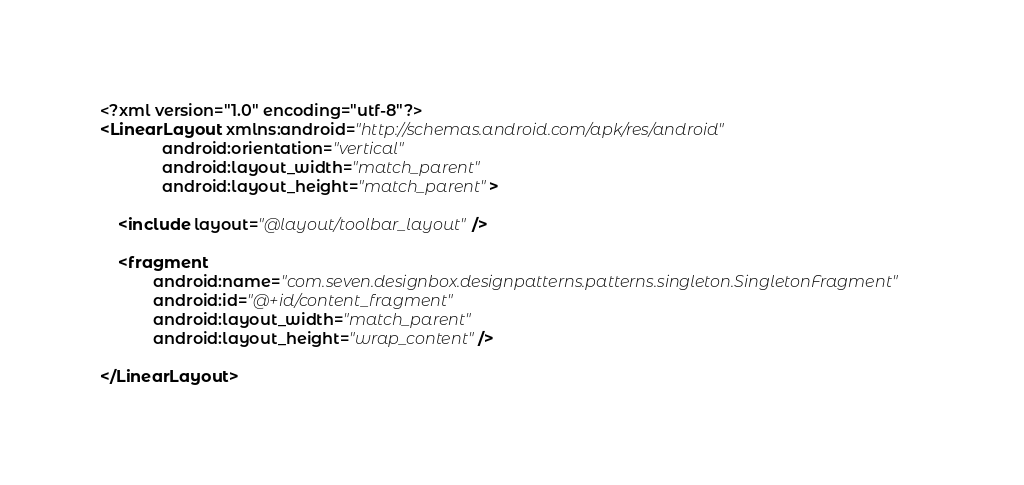<code> <loc_0><loc_0><loc_500><loc_500><_XML_><?xml version="1.0" encoding="utf-8"?>
<LinearLayout xmlns:android="http://schemas.android.com/apk/res/android"
              android:orientation="vertical"
              android:layout_width="match_parent"
              android:layout_height="match_parent">

    <include layout="@layout/toolbar_layout"/>

    <fragment
            android:name="com.seven.designbox.designpatterns.patterns.singleton.SingletonFragment"
            android:id="@+id/content_fragment"
            android:layout_width="match_parent"
            android:layout_height="wrap_content"/>

</LinearLayout></code> 